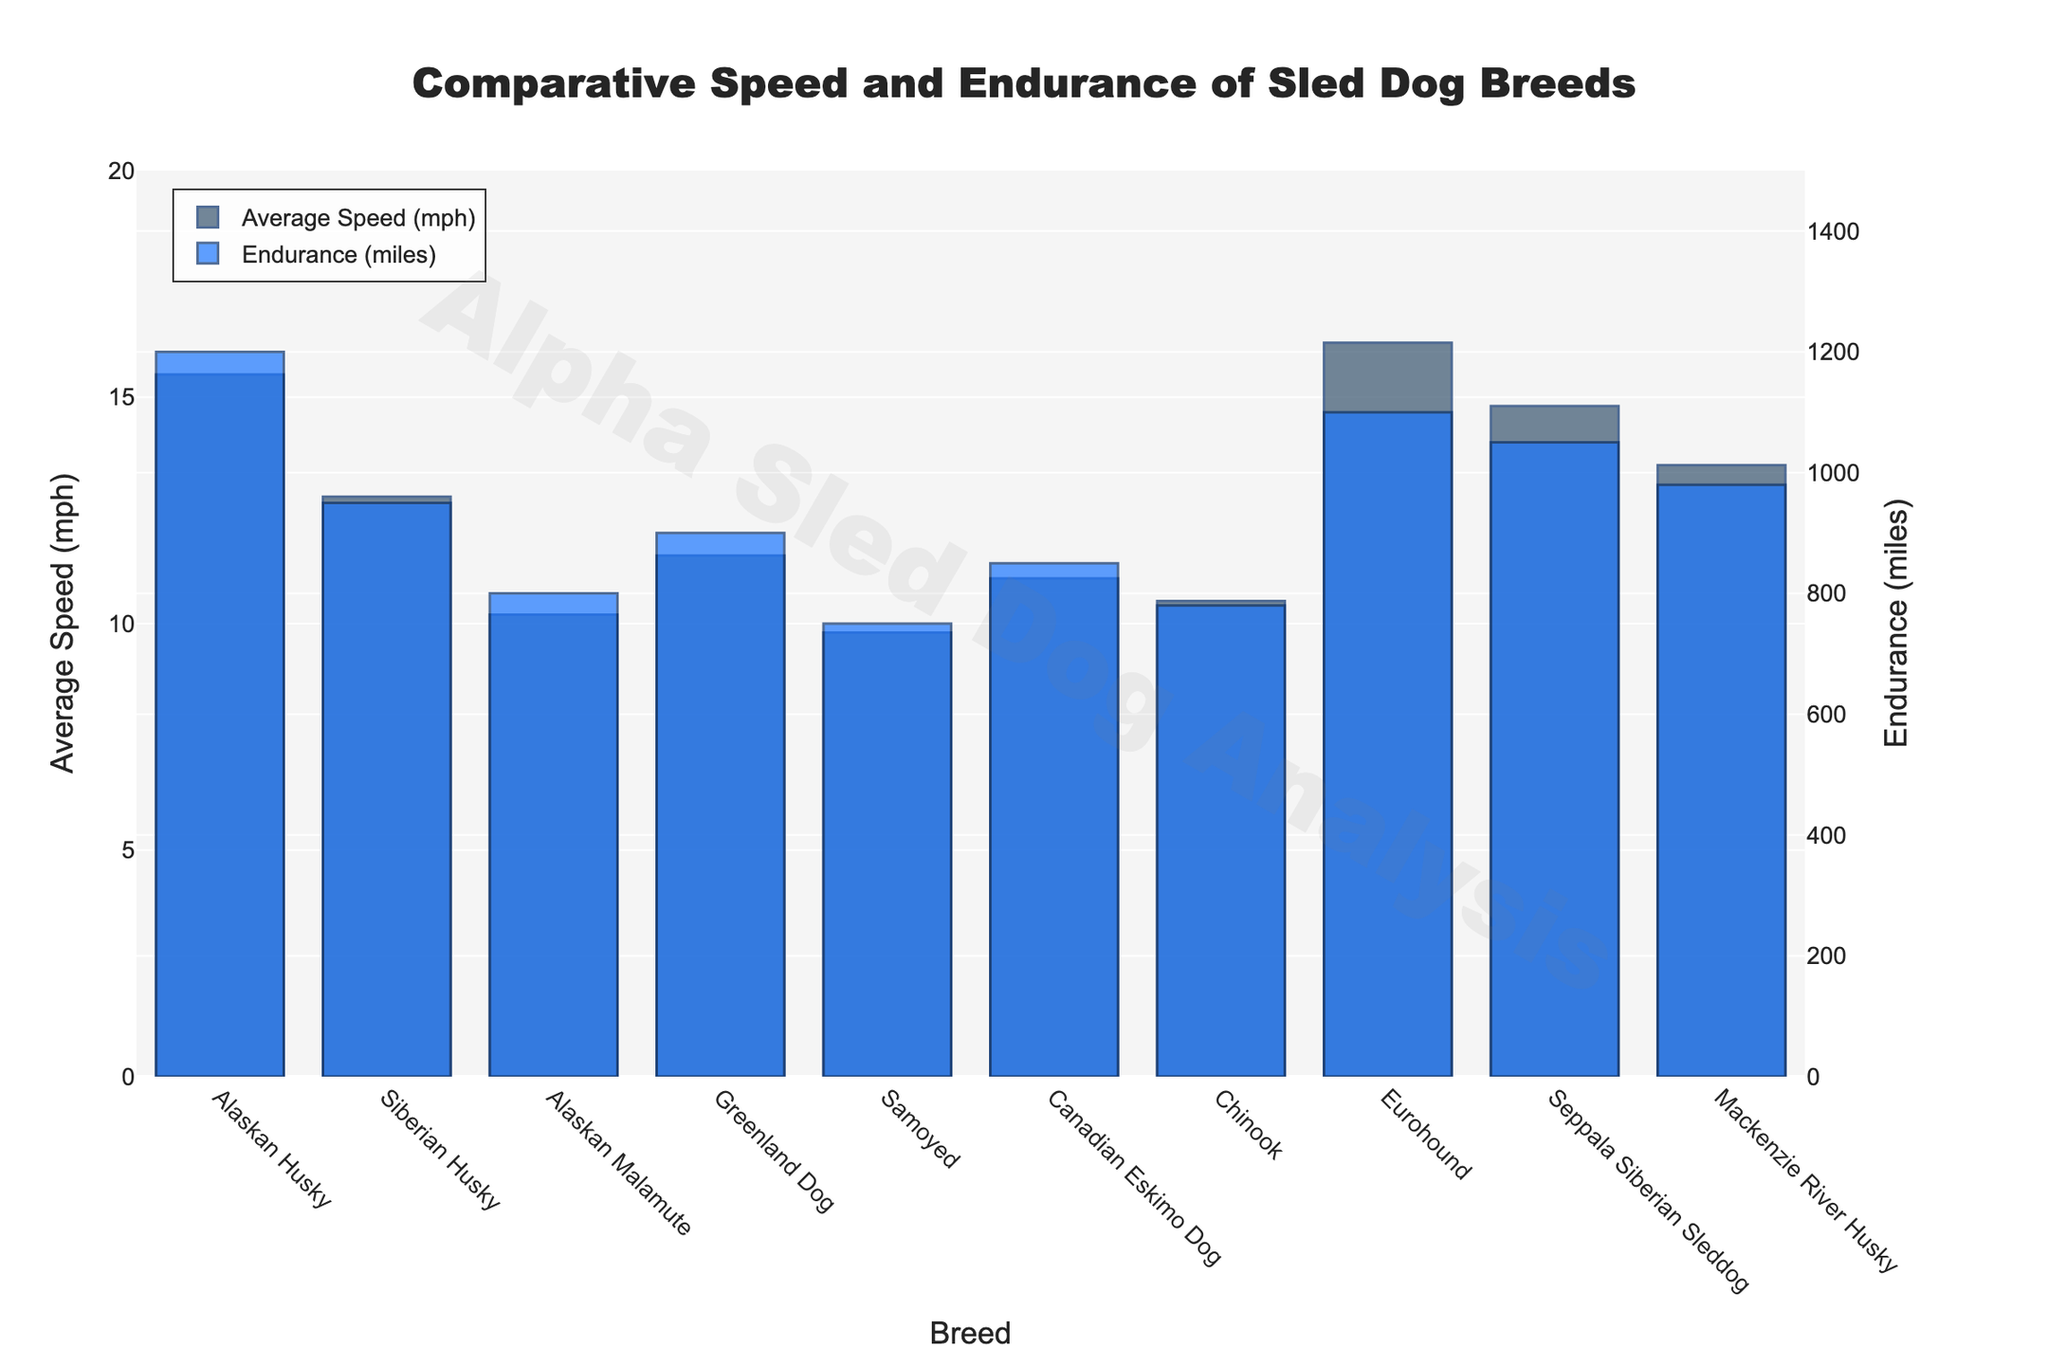Which breed has the highest average speed? The highest bar in the "Average Speed (mph)" category indicates the breed with the highest average speed. The Eurohound has the tallest bar.
Answer: Eurohound Which breed has the greatest endurance? The tallest bar in the "Endurance (miles)" category signifies the breed with the greatest endurance. The Alaskan Husky has the tallest bar.
Answer: Alaskan Husky Which breed has the lower average speed, the Samoyed or the Alaskan Malamute? Comparing the heights of the bars in the "Average Speed (mph)" category for Samoyed and Alaskan Malamute, the Samoyed's bar is shorter.
Answer: Samoyed What is the difference in endurance between the Greenland Dog and the Canadian Eskimo Dog? Subtract the endurance (miles) indicated by the bar of the Canadian Eskimo Dog from that of the Greenland Dog. (900 - 850).
Answer: 50 miles Which breeds have an average speed greater than 14 mph? Identify the bars in the "Average Speed (mph)" category that surpass the 14 mph mark. The breeds are Alaskan Husky, Eurohound, Seppala Siberian Sleddog, and Mackenzie River Husky.
Answer: Alaskan Husky, Eurohound, Seppala Siberian Sleddog, Mackenzie River Husky Which breed has a higher average speed, the Siberian Husky or the Mackenzie River Husky? Comparing the heights of the bars in the "Average Speed (mph)" category for both breeds, Mackenzie River Husky's bar is higher.
Answer: Mackenzie River Husky How much farther can an Alaskan Husky run compared to a Samoyed? Subtract the endurance (miles) indicated by the bar of the Samoyed from that of the Alaskan Husky. (1200 - 750).
Answer: 450 miles What is the sum of the average speeds of the Alaskan Malamute and Chinook? Add the average speeds (mph) as indicated by the bars. (10.2 + 10.5).
Answer: 20.7 mph What is the median endurance of the listed breeds? Arrange the endurance values in ascending order: 750, 780, 800, 850, 900, 950, 980, 1050, 1100, 1200. The median values are the 5th and 6th values, so the median is (900 + 950) / 2 = 925.
Answer: 925 miles 